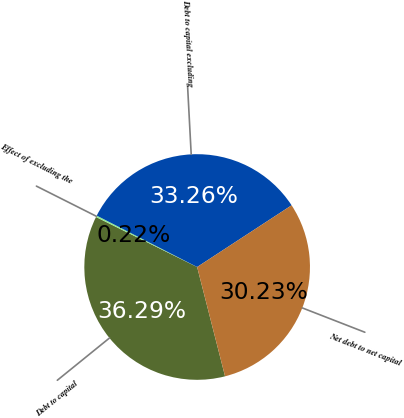<chart> <loc_0><loc_0><loc_500><loc_500><pie_chart><fcel>Debt to capital<fcel>Effect of excluding the<fcel>Debt to capital excluding<fcel>Net debt to net capital<nl><fcel>36.29%<fcel>0.22%<fcel>33.26%<fcel>30.23%<nl></chart> 